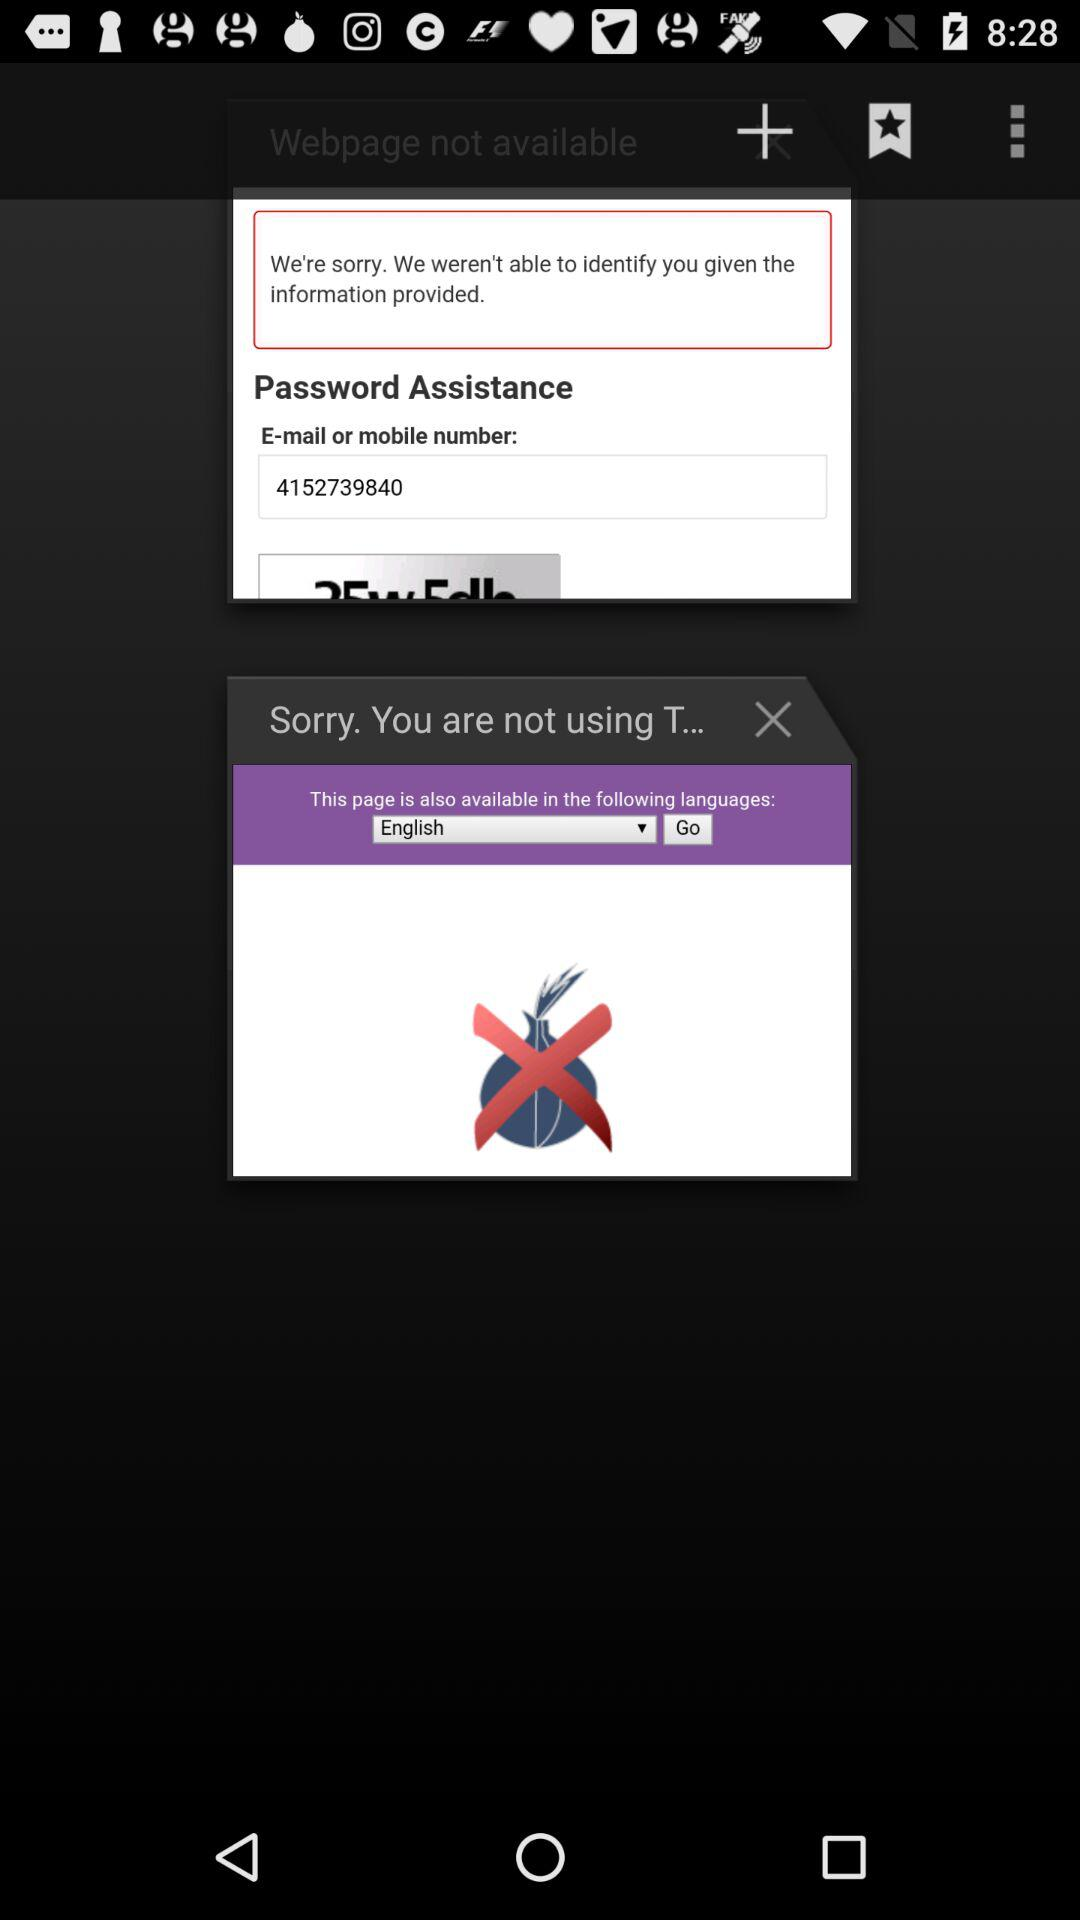What is the mobile number that was given for the information? The mobile number that was given for information is 4152739840. 